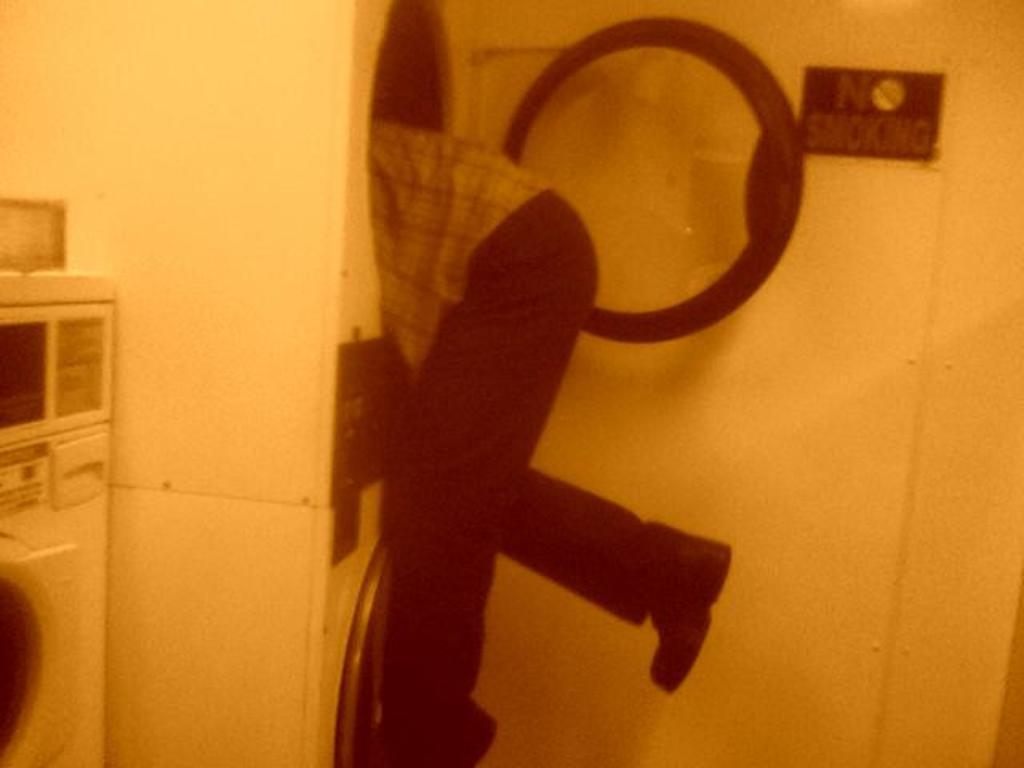What is the person in the image doing? There is a person inside a washing machine in the image. What can be seen on the left side of the image? There is another washing machine on the left side of the image. What is present in the top right of the image? There is a caution board in the top right of the image. What type of sidewalk can be seen in the image? There is no sidewalk present in the image. 